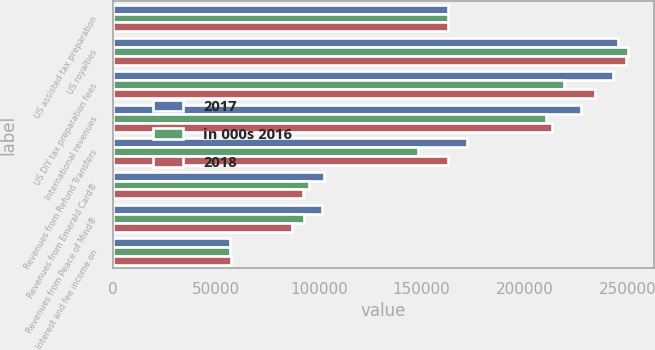Convert chart. <chart><loc_0><loc_0><loc_500><loc_500><stacked_bar_chart><ecel><fcel>US assisted tax preparation<fcel>US royalties<fcel>US DIY tax preparation fees<fcel>International revenues<fcel>Revenues from Refund Transfers<fcel>Revenues from Emerald Card®<fcel>Revenues from Peace of Mind®<fcel>Interest and fee income on<nl><fcel>2017<fcel>162560<fcel>245444<fcel>243159<fcel>227266<fcel>171959<fcel>102640<fcel>101572<fcel>56986<nl><fcel>in 000s 2016<fcel>162560<fcel>250270<fcel>219123<fcel>210320<fcel>148212<fcel>95221<fcel>92820<fcel>57022<nl><fcel>2018<fcel>162560<fcel>249433<fcel>234341<fcel>213400<fcel>162560<fcel>92608<fcel>86830<fcel>57268<nl></chart> 